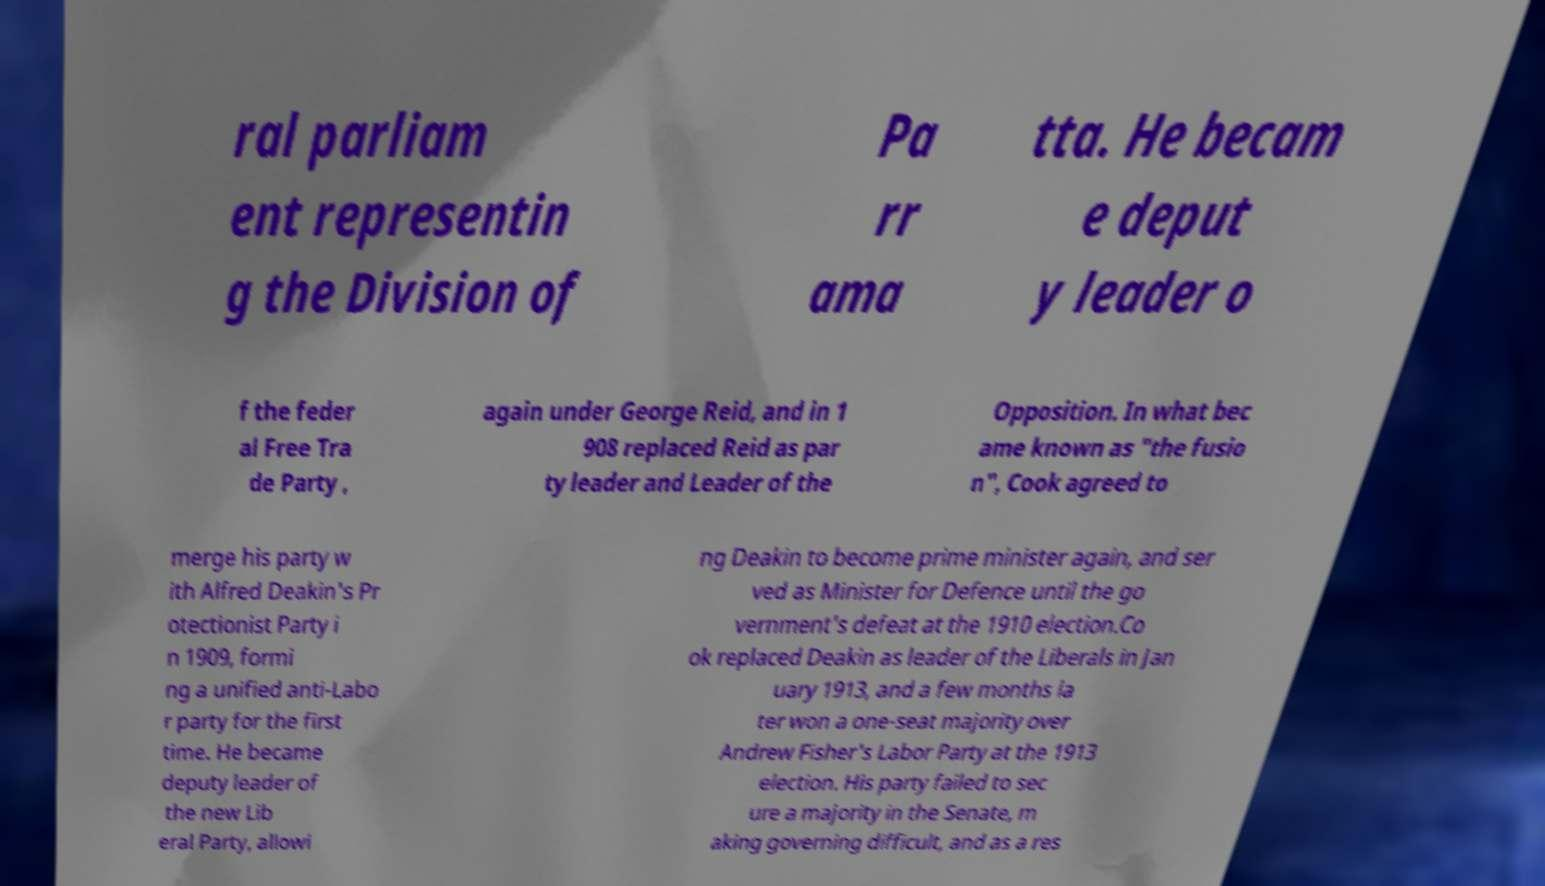For documentation purposes, I need the text within this image transcribed. Could you provide that? ral parliam ent representin g the Division of Pa rr ama tta. He becam e deput y leader o f the feder al Free Tra de Party , again under George Reid, and in 1 908 replaced Reid as par ty leader and Leader of the Opposition. In what bec ame known as "the fusio n", Cook agreed to merge his party w ith Alfred Deakin's Pr otectionist Party i n 1909, formi ng a unified anti-Labo r party for the first time. He became deputy leader of the new Lib eral Party, allowi ng Deakin to become prime minister again, and ser ved as Minister for Defence until the go vernment's defeat at the 1910 election.Co ok replaced Deakin as leader of the Liberals in Jan uary 1913, and a few months la ter won a one-seat majority over Andrew Fisher's Labor Party at the 1913 election. His party failed to sec ure a majority in the Senate, m aking governing difficult, and as a res 